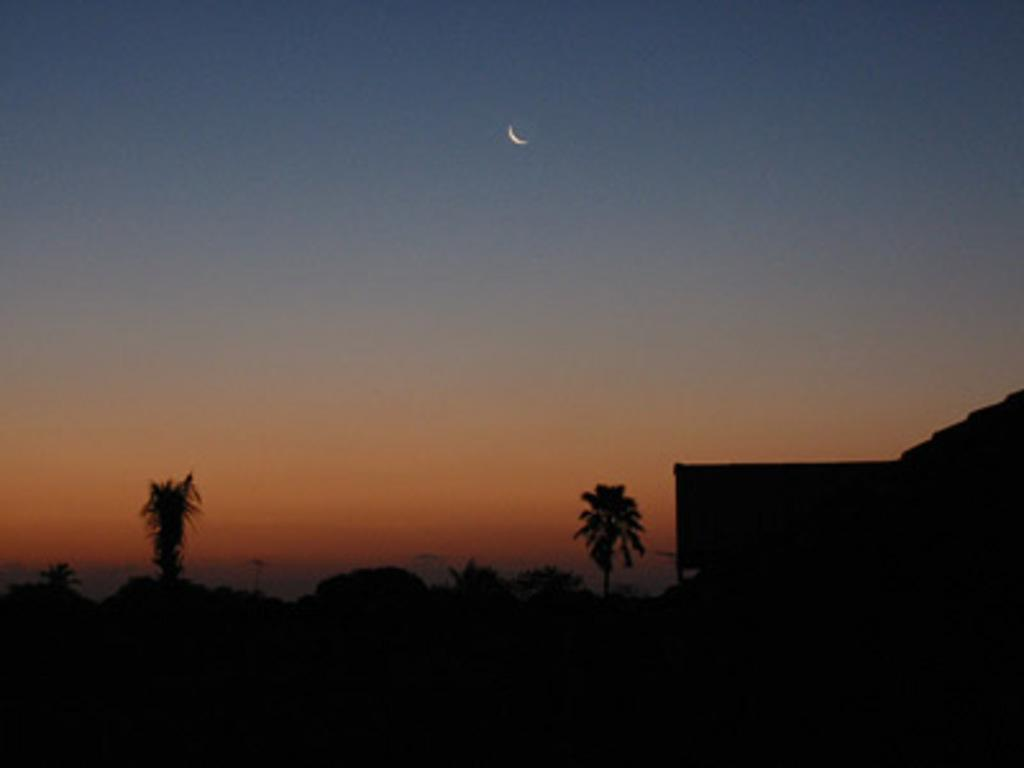What type of vegetation can be seen in the image? There are trees in the image. What part of the natural environment is visible in the image? The sky is visible in the image. What type of shop can be seen in the image? There is no shop present in the image; it features trees and the sky. What type of division is taking place in the image? There is no division taking place in the image; it simply shows trees and the sky. 